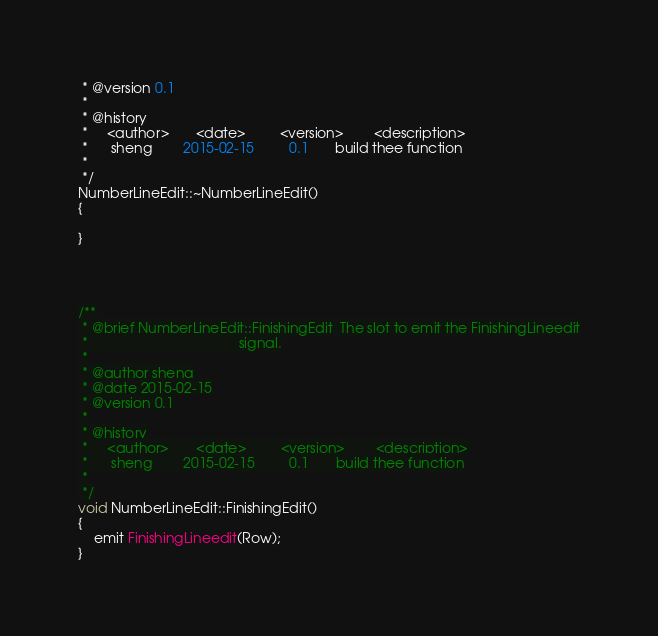<code> <loc_0><loc_0><loc_500><loc_500><_C++_> * @version 0.1
 *
 * @history
 *     <author>       <date>         <version>        <description>
 *      sheng        2015-02-15         0.1       build thee function
 *
 */
NumberLineEdit::~NumberLineEdit()
{

}




/**
 * @brief NumberLineEdit::FinishingEdit  The slot to emit the FinishingLineedit
 *                                       signal.
 *
 * @author sheng
 * @date 2015-02-15
 * @version 0.1
 *
 * @history
 *     <author>       <date>         <version>        <description>
 *      sheng        2015-02-15         0.1       build thee function
 *
 */
void NumberLineEdit::FinishingEdit()
{
    emit FinishingLineedit(Row);
}



</code> 